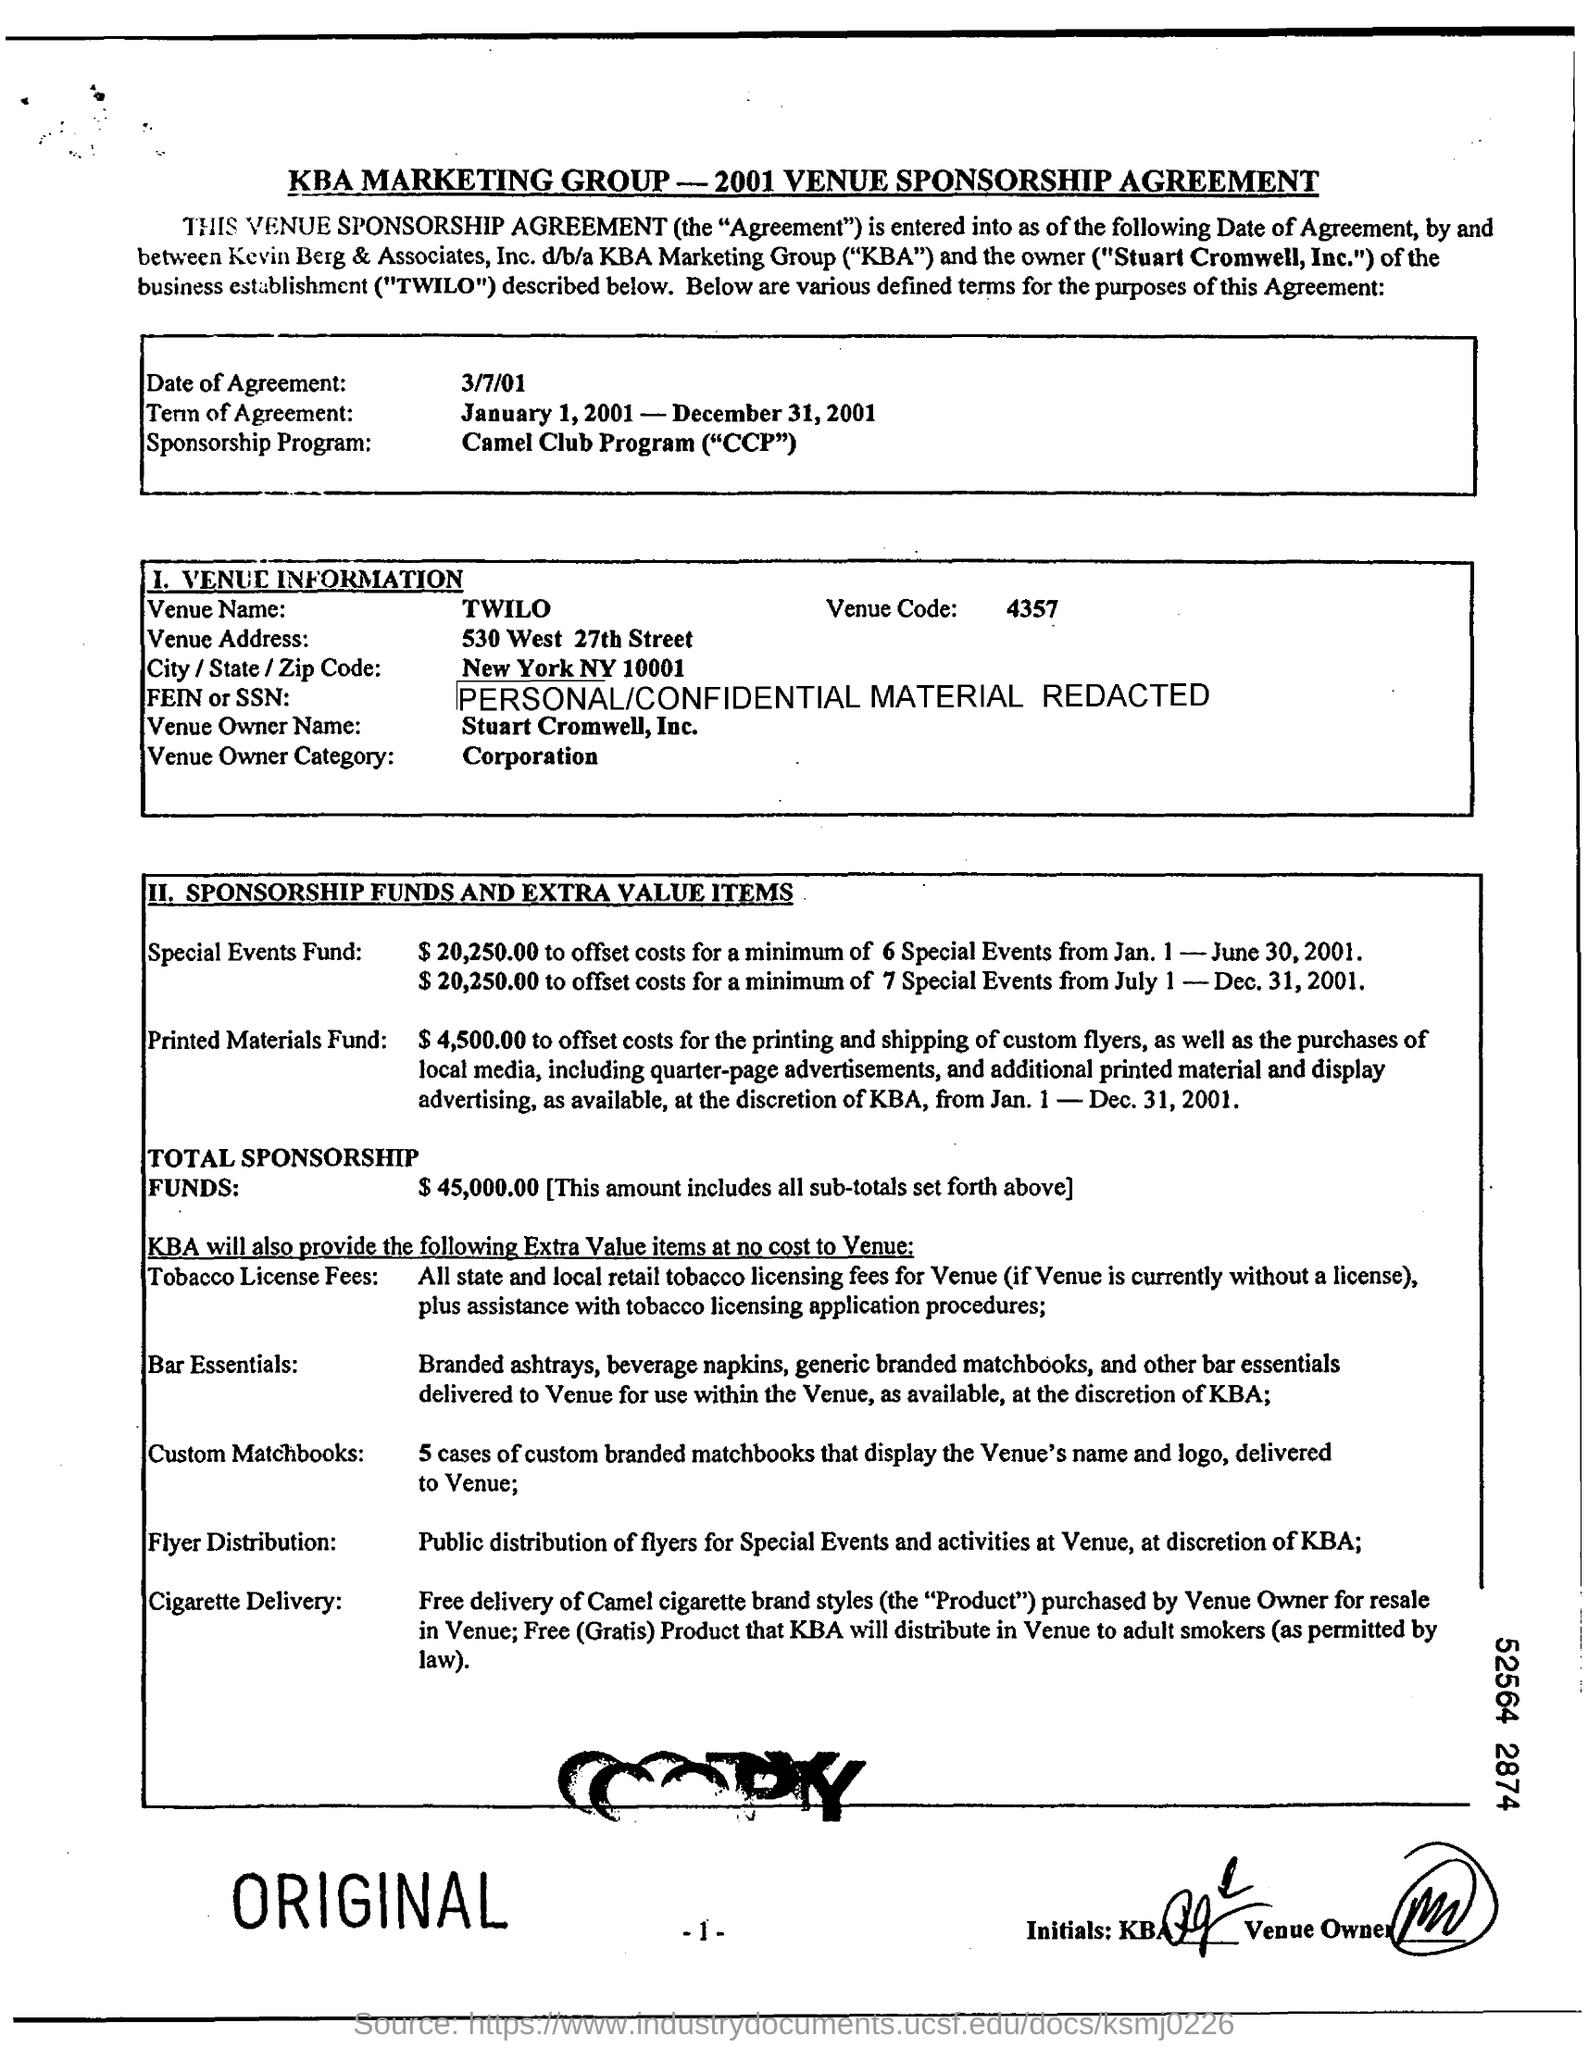What are the financial details mentioned in the document? The document details a Total Sponsorship Fund of $45,000, along with specific allocations for special events, printed materials, and extra value items such as tobacco license fees, bar essentials, and flyer distribution. 